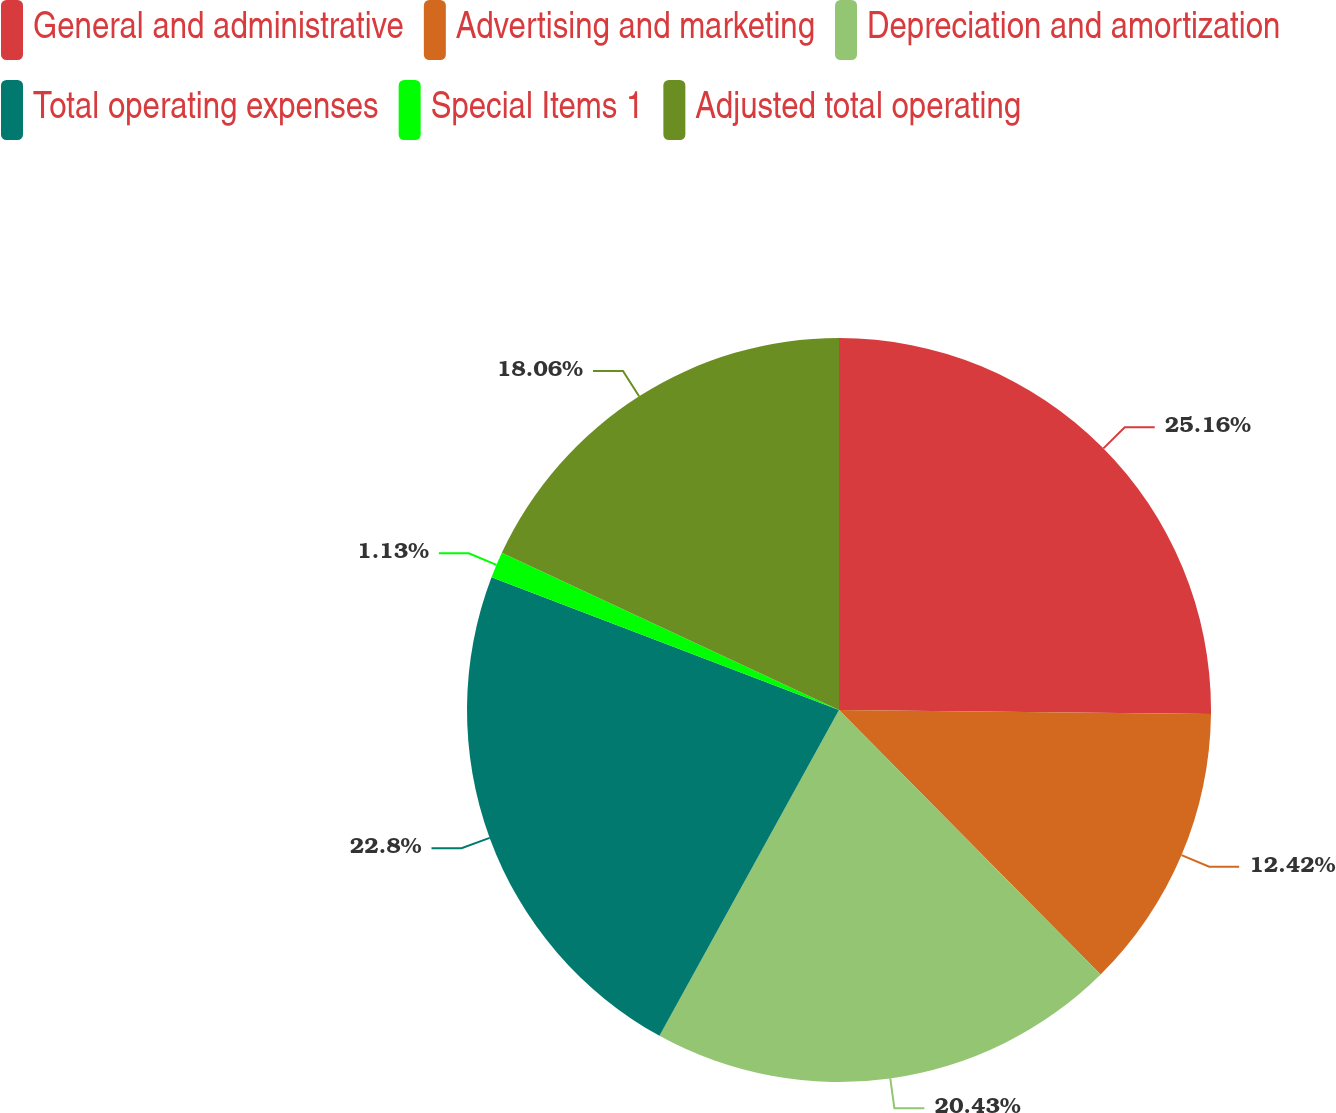<chart> <loc_0><loc_0><loc_500><loc_500><pie_chart><fcel>General and administrative<fcel>Advertising and marketing<fcel>Depreciation and amortization<fcel>Total operating expenses<fcel>Special Items 1<fcel>Adjusted total operating<nl><fcel>25.17%<fcel>12.42%<fcel>20.43%<fcel>22.8%<fcel>1.13%<fcel>18.06%<nl></chart> 